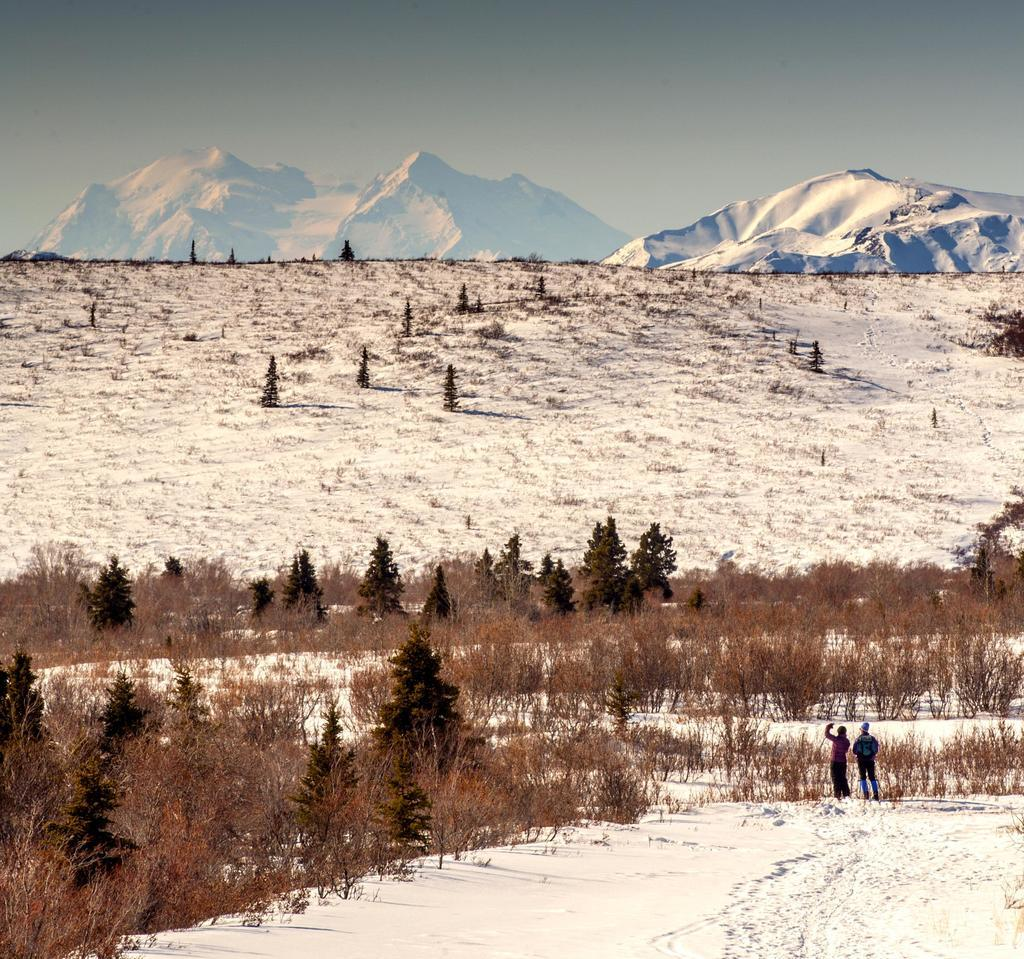How many people are in the image? There are two people standing in the image. What is in front of the people? There are trees in front of the people. What type of landscape can be seen in the image? Snowy hills are visible in the image. What is visible in the sky? The sky is visible in the image. What type of pie is being served on the orange table in the image? There is no pie or orange table present in the image. 